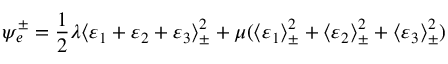Convert formula to latex. <formula><loc_0><loc_0><loc_500><loc_500>\psi _ { e } ^ { \pm } = \frac { 1 } { 2 } \lambda \langle \varepsilon _ { 1 } + \varepsilon _ { 2 } + \varepsilon _ { 3 } \rangle _ { \pm } ^ { 2 } + \mu ( \langle \varepsilon _ { 1 } \rangle _ { \pm } ^ { 2 } + \langle \varepsilon _ { 2 } \rangle _ { \pm } ^ { 2 } + \langle \varepsilon _ { 3 } \rangle _ { \pm } ^ { 2 } )</formula> 